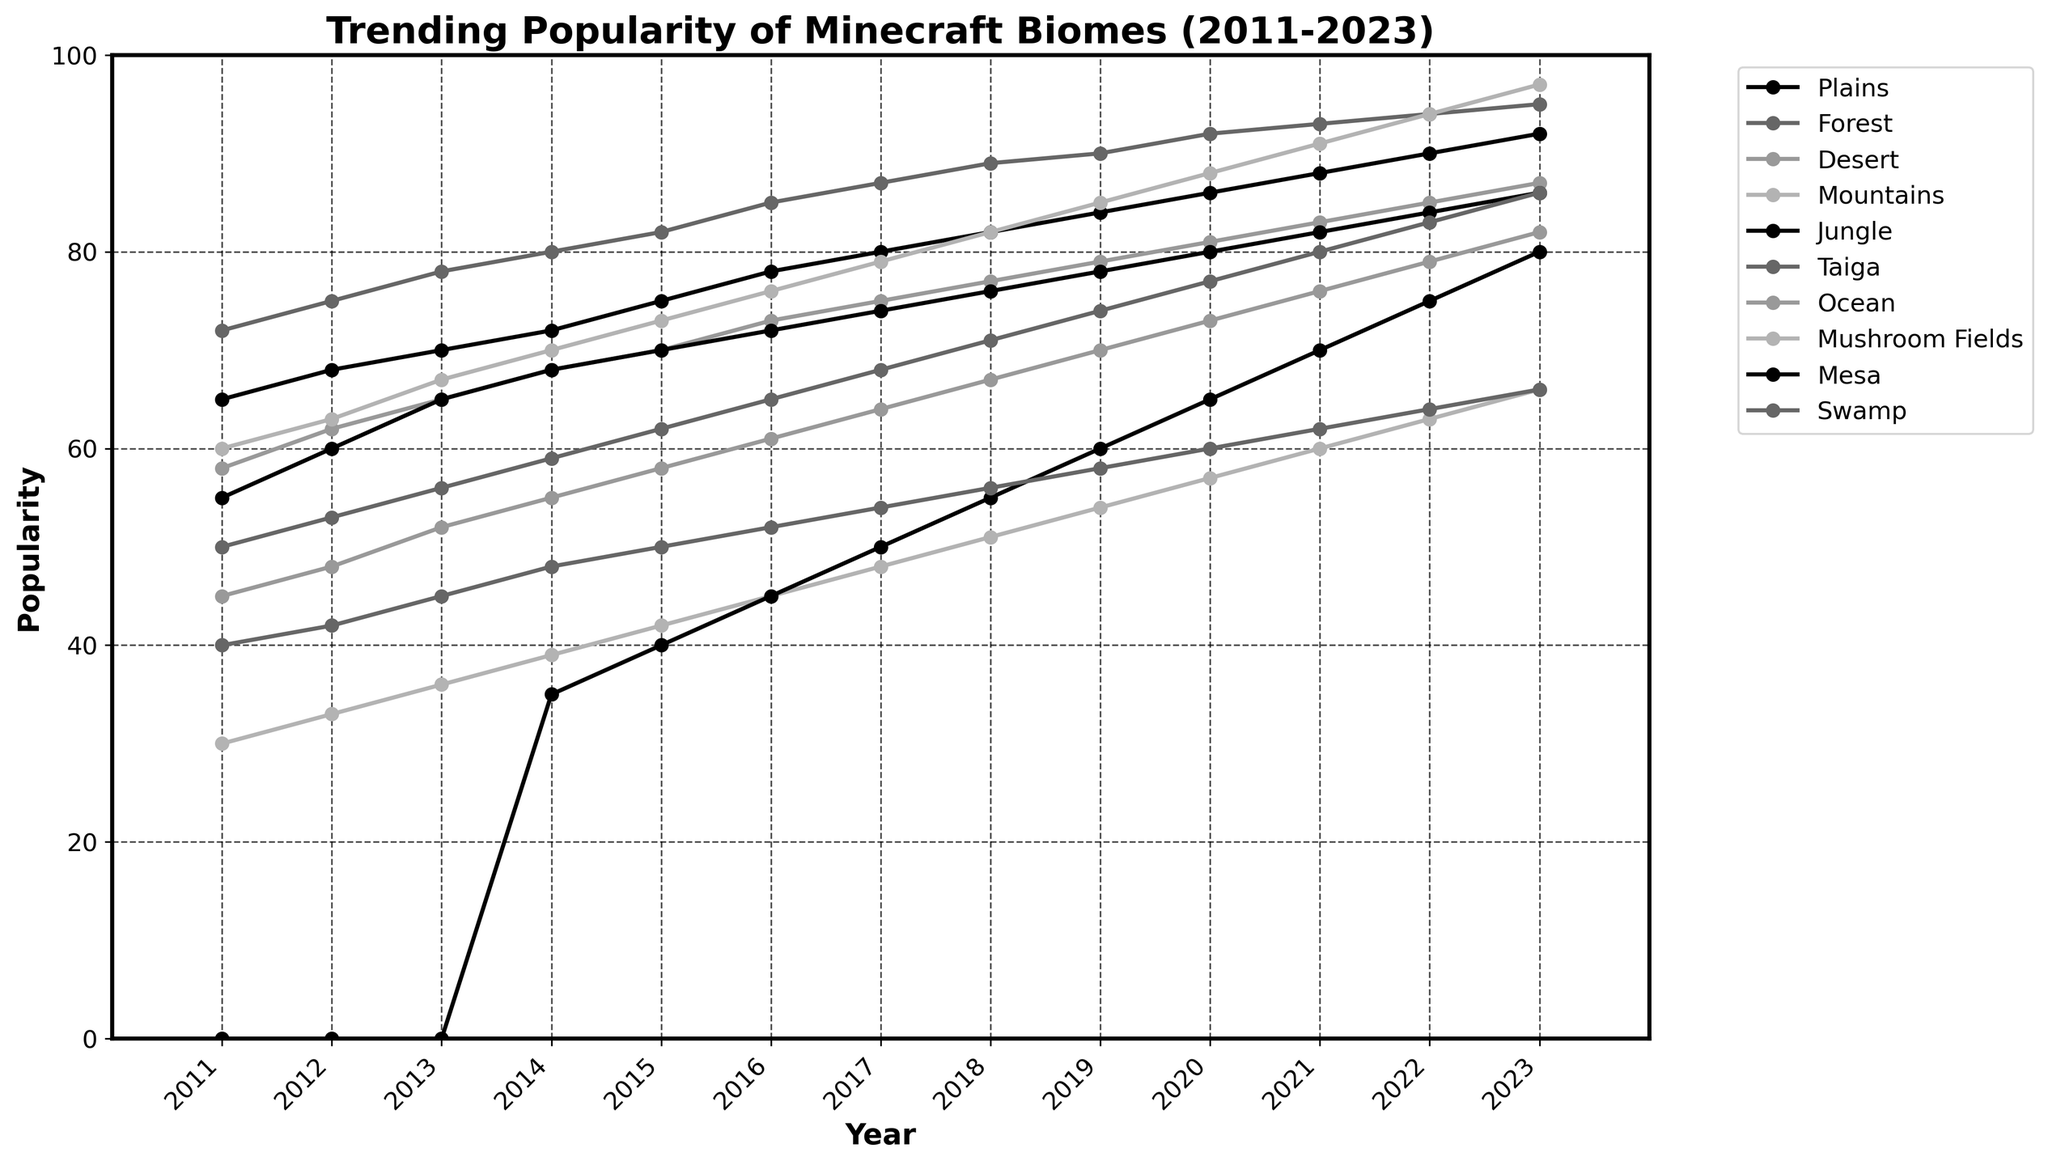Which biome had the highest popularity in 2023? Look at the end of each line in 2023, find the height of the lines and compare them. The "Forest" line is at the top.
Answer: Forest How did the popularity of the Desert biome change from 2011 to 2023? Check the "Desert" line at 2011 and 2023. It started at 58 in 2011 and increased to 87 in 2023.
Answer: Increased Which two biomes had equal popularity in 2011, and what was that value? Look at each line's value for 2011 and find where they match. Both the "Plains" and "Mountains" were at 60.
Answer: Plains and Mountains, 60 What is the average annual increase in popularity for the Jungle biome from 2011 to 2023? Find the difference in the Jungle biome's popularity from 2011 (55) to 2023 (86), then divide by the number of years (12). (86 - 55) / 12 = 2.58
Answer: 2.58 Which biome saw the largest increase in popularity from 2011 to 2023? Calculate the popularity increase for each biome by subtracting 2011 values from 2023 values. The Forest biome increased the most (95 - 72 = 23).
Answer: Forest Between 2017 and 2020, which biome saw the most significant increase in popularity? Compare the popularity values of all biomes for these years and find the one with the greatest difference. Forest saw the most significant increase from 87 in 2017 to 92 in 2020, an increase of 5.
Answer: Forest During which year did the Mushroom Fields biome first exceed a popularity value of 50? Observe the line for Mushroom Fields and find the first year the value goes beyond 50. This happened in 2018.
Answer: 2018 What was the difference in popularity between the Ocean and Swamp biomes in 2020? Subtract the popularity values of Swamp (60) from Ocean (73) for 2020. 73 - 60 = 13
Answer: 13 Which biome had the least popularity in 2011, and what was its value? Look at the smallest value among all the biomes in 2011. Mushroom Fields had the least popularity with 30.
Answer: Mushroom Fields, 30 In which year did the popularity of the Mesa biome reach 45 for the first time? Trace the Mesa line through the years and find where it first reaches 45. This happened in 2016.
Answer: 2016 